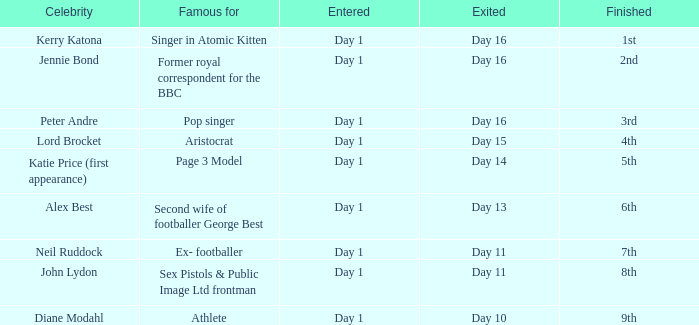Specify the individual celebrated for finishing 9th. Athlete. 